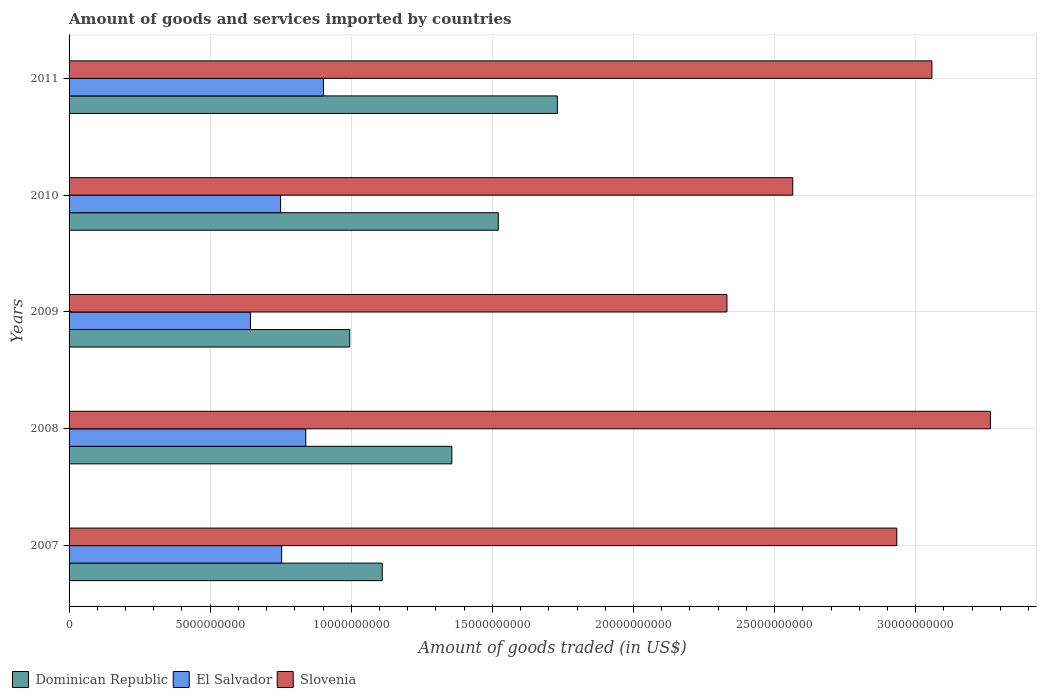Are the number of bars per tick equal to the number of legend labels?
Keep it short and to the point. Yes. What is the total amount of goods and services imported in Slovenia in 2010?
Your answer should be compact. 2.56e+1. Across all years, what is the maximum total amount of goods and services imported in Slovenia?
Ensure brevity in your answer.  3.26e+1. Across all years, what is the minimum total amount of goods and services imported in El Salvador?
Make the answer very short. 6.43e+09. In which year was the total amount of goods and services imported in Slovenia minimum?
Offer a terse response. 2009. What is the total total amount of goods and services imported in Dominican Republic in the graph?
Offer a terse response. 6.71e+1. What is the difference between the total amount of goods and services imported in Dominican Republic in 2010 and that in 2011?
Give a very brief answer. -2.09e+09. What is the difference between the total amount of goods and services imported in Dominican Republic in 2010 and the total amount of goods and services imported in El Salvador in 2008?
Provide a short and direct response. 6.82e+09. What is the average total amount of goods and services imported in Dominican Republic per year?
Your answer should be compact. 1.34e+1. In the year 2009, what is the difference between the total amount of goods and services imported in Dominican Republic and total amount of goods and services imported in El Salvador?
Your response must be concise. 3.52e+09. What is the ratio of the total amount of goods and services imported in El Salvador in 2008 to that in 2009?
Ensure brevity in your answer.  1.3. Is the difference between the total amount of goods and services imported in Dominican Republic in 2010 and 2011 greater than the difference between the total amount of goods and services imported in El Salvador in 2010 and 2011?
Your answer should be compact. No. What is the difference between the highest and the second highest total amount of goods and services imported in Dominican Republic?
Give a very brief answer. 2.09e+09. What is the difference between the highest and the lowest total amount of goods and services imported in Slovenia?
Ensure brevity in your answer.  9.34e+09. In how many years, is the total amount of goods and services imported in El Salvador greater than the average total amount of goods and services imported in El Salvador taken over all years?
Provide a succinct answer. 2. Is the sum of the total amount of goods and services imported in Dominican Republic in 2007 and 2011 greater than the maximum total amount of goods and services imported in El Salvador across all years?
Your answer should be very brief. Yes. What does the 3rd bar from the top in 2008 represents?
Make the answer very short. Dominican Republic. What does the 1st bar from the bottom in 2007 represents?
Offer a very short reply. Dominican Republic. How many bars are there?
Your answer should be very brief. 15. What is the difference between two consecutive major ticks on the X-axis?
Make the answer very short. 5.00e+09. Does the graph contain grids?
Your answer should be very brief. Yes. How many legend labels are there?
Your answer should be compact. 3. How are the legend labels stacked?
Your answer should be very brief. Horizontal. What is the title of the graph?
Provide a short and direct response. Amount of goods and services imported by countries. What is the label or title of the X-axis?
Make the answer very short. Amount of goods traded (in US$). What is the Amount of goods traded (in US$) in Dominican Republic in 2007?
Offer a terse response. 1.11e+1. What is the Amount of goods traded (in US$) of El Salvador in 2007?
Provide a succinct answer. 7.53e+09. What is the Amount of goods traded (in US$) in Slovenia in 2007?
Your response must be concise. 2.93e+1. What is the Amount of goods traded (in US$) of Dominican Republic in 2008?
Provide a short and direct response. 1.36e+1. What is the Amount of goods traded (in US$) in El Salvador in 2008?
Your response must be concise. 8.39e+09. What is the Amount of goods traded (in US$) in Slovenia in 2008?
Offer a terse response. 3.26e+1. What is the Amount of goods traded (in US$) in Dominican Republic in 2009?
Give a very brief answer. 9.95e+09. What is the Amount of goods traded (in US$) in El Salvador in 2009?
Give a very brief answer. 6.43e+09. What is the Amount of goods traded (in US$) in Slovenia in 2009?
Make the answer very short. 2.33e+1. What is the Amount of goods traded (in US$) of Dominican Republic in 2010?
Your answer should be compact. 1.52e+1. What is the Amount of goods traded (in US$) of El Salvador in 2010?
Offer a very short reply. 7.50e+09. What is the Amount of goods traded (in US$) of Slovenia in 2010?
Offer a very short reply. 2.56e+1. What is the Amount of goods traded (in US$) of Dominican Republic in 2011?
Offer a very short reply. 1.73e+1. What is the Amount of goods traded (in US$) of El Salvador in 2011?
Your answer should be compact. 9.01e+09. What is the Amount of goods traded (in US$) of Slovenia in 2011?
Provide a short and direct response. 3.06e+1. Across all years, what is the maximum Amount of goods traded (in US$) in Dominican Republic?
Offer a terse response. 1.73e+1. Across all years, what is the maximum Amount of goods traded (in US$) in El Salvador?
Make the answer very short. 9.01e+09. Across all years, what is the maximum Amount of goods traded (in US$) in Slovenia?
Your answer should be compact. 3.26e+1. Across all years, what is the minimum Amount of goods traded (in US$) of Dominican Republic?
Offer a terse response. 9.95e+09. Across all years, what is the minimum Amount of goods traded (in US$) in El Salvador?
Keep it short and to the point. 6.43e+09. Across all years, what is the minimum Amount of goods traded (in US$) of Slovenia?
Keep it short and to the point. 2.33e+1. What is the total Amount of goods traded (in US$) in Dominican Republic in the graph?
Your answer should be compact. 6.71e+1. What is the total Amount of goods traded (in US$) in El Salvador in the graph?
Keep it short and to the point. 3.89e+1. What is the total Amount of goods traded (in US$) in Slovenia in the graph?
Give a very brief answer. 1.42e+11. What is the difference between the Amount of goods traded (in US$) in Dominican Republic in 2007 and that in 2008?
Provide a succinct answer. -2.47e+09. What is the difference between the Amount of goods traded (in US$) in El Salvador in 2007 and that in 2008?
Give a very brief answer. -8.55e+08. What is the difference between the Amount of goods traded (in US$) in Slovenia in 2007 and that in 2008?
Provide a short and direct response. -3.32e+09. What is the difference between the Amount of goods traded (in US$) of Dominican Republic in 2007 and that in 2009?
Your answer should be compact. 1.15e+09. What is the difference between the Amount of goods traded (in US$) of El Salvador in 2007 and that in 2009?
Your answer should be compact. 1.10e+09. What is the difference between the Amount of goods traded (in US$) in Slovenia in 2007 and that in 2009?
Offer a terse response. 6.02e+09. What is the difference between the Amount of goods traded (in US$) of Dominican Republic in 2007 and that in 2010?
Your answer should be very brief. -4.11e+09. What is the difference between the Amount of goods traded (in US$) of El Salvador in 2007 and that in 2010?
Offer a terse response. 3.86e+07. What is the difference between the Amount of goods traded (in US$) of Slovenia in 2007 and that in 2010?
Give a very brief answer. 3.69e+09. What is the difference between the Amount of goods traded (in US$) of Dominican Republic in 2007 and that in 2011?
Provide a succinct answer. -6.20e+09. What is the difference between the Amount of goods traded (in US$) in El Salvador in 2007 and that in 2011?
Offer a terse response. -1.48e+09. What is the difference between the Amount of goods traded (in US$) in Slovenia in 2007 and that in 2011?
Your answer should be very brief. -1.24e+09. What is the difference between the Amount of goods traded (in US$) of Dominican Republic in 2008 and that in 2009?
Your answer should be compact. 3.62e+09. What is the difference between the Amount of goods traded (in US$) in El Salvador in 2008 and that in 2009?
Give a very brief answer. 1.96e+09. What is the difference between the Amount of goods traded (in US$) of Slovenia in 2008 and that in 2009?
Your answer should be very brief. 9.34e+09. What is the difference between the Amount of goods traded (in US$) of Dominican Republic in 2008 and that in 2010?
Ensure brevity in your answer.  -1.65e+09. What is the difference between the Amount of goods traded (in US$) in El Salvador in 2008 and that in 2010?
Offer a very short reply. 8.93e+08. What is the difference between the Amount of goods traded (in US$) of Slovenia in 2008 and that in 2010?
Offer a terse response. 7.00e+09. What is the difference between the Amount of goods traded (in US$) of Dominican Republic in 2008 and that in 2011?
Offer a terse response. -3.74e+09. What is the difference between the Amount of goods traded (in US$) of El Salvador in 2008 and that in 2011?
Keep it short and to the point. -6.26e+08. What is the difference between the Amount of goods traded (in US$) in Slovenia in 2008 and that in 2011?
Keep it short and to the point. 2.07e+09. What is the difference between the Amount of goods traded (in US$) of Dominican Republic in 2009 and that in 2010?
Offer a very short reply. -5.26e+09. What is the difference between the Amount of goods traded (in US$) of El Salvador in 2009 and that in 2010?
Provide a short and direct response. -1.07e+09. What is the difference between the Amount of goods traded (in US$) of Slovenia in 2009 and that in 2010?
Offer a terse response. -2.33e+09. What is the difference between the Amount of goods traded (in US$) in Dominican Republic in 2009 and that in 2011?
Your answer should be very brief. -7.36e+09. What is the difference between the Amount of goods traded (in US$) of El Salvador in 2009 and that in 2011?
Provide a succinct answer. -2.58e+09. What is the difference between the Amount of goods traded (in US$) in Slovenia in 2009 and that in 2011?
Keep it short and to the point. -7.26e+09. What is the difference between the Amount of goods traded (in US$) in Dominican Republic in 2010 and that in 2011?
Give a very brief answer. -2.09e+09. What is the difference between the Amount of goods traded (in US$) in El Salvador in 2010 and that in 2011?
Give a very brief answer. -1.52e+09. What is the difference between the Amount of goods traded (in US$) of Slovenia in 2010 and that in 2011?
Offer a terse response. -4.93e+09. What is the difference between the Amount of goods traded (in US$) in Dominican Republic in 2007 and the Amount of goods traded (in US$) in El Salvador in 2008?
Ensure brevity in your answer.  2.71e+09. What is the difference between the Amount of goods traded (in US$) of Dominican Republic in 2007 and the Amount of goods traded (in US$) of Slovenia in 2008?
Offer a very short reply. -2.16e+1. What is the difference between the Amount of goods traded (in US$) of El Salvador in 2007 and the Amount of goods traded (in US$) of Slovenia in 2008?
Ensure brevity in your answer.  -2.51e+1. What is the difference between the Amount of goods traded (in US$) in Dominican Republic in 2007 and the Amount of goods traded (in US$) in El Salvador in 2009?
Your answer should be compact. 4.67e+09. What is the difference between the Amount of goods traded (in US$) in Dominican Republic in 2007 and the Amount of goods traded (in US$) in Slovenia in 2009?
Keep it short and to the point. -1.22e+1. What is the difference between the Amount of goods traded (in US$) of El Salvador in 2007 and the Amount of goods traded (in US$) of Slovenia in 2009?
Provide a short and direct response. -1.58e+1. What is the difference between the Amount of goods traded (in US$) of Dominican Republic in 2007 and the Amount of goods traded (in US$) of El Salvador in 2010?
Provide a succinct answer. 3.60e+09. What is the difference between the Amount of goods traded (in US$) in Dominican Republic in 2007 and the Amount of goods traded (in US$) in Slovenia in 2010?
Your response must be concise. -1.45e+1. What is the difference between the Amount of goods traded (in US$) in El Salvador in 2007 and the Amount of goods traded (in US$) in Slovenia in 2010?
Your response must be concise. -1.81e+1. What is the difference between the Amount of goods traded (in US$) of Dominican Republic in 2007 and the Amount of goods traded (in US$) of El Salvador in 2011?
Give a very brief answer. 2.08e+09. What is the difference between the Amount of goods traded (in US$) in Dominican Republic in 2007 and the Amount of goods traded (in US$) in Slovenia in 2011?
Your answer should be compact. -1.95e+1. What is the difference between the Amount of goods traded (in US$) in El Salvador in 2007 and the Amount of goods traded (in US$) in Slovenia in 2011?
Offer a very short reply. -2.30e+1. What is the difference between the Amount of goods traded (in US$) of Dominican Republic in 2008 and the Amount of goods traded (in US$) of El Salvador in 2009?
Provide a succinct answer. 7.13e+09. What is the difference between the Amount of goods traded (in US$) in Dominican Republic in 2008 and the Amount of goods traded (in US$) in Slovenia in 2009?
Provide a short and direct response. -9.75e+09. What is the difference between the Amount of goods traded (in US$) of El Salvador in 2008 and the Amount of goods traded (in US$) of Slovenia in 2009?
Provide a succinct answer. -1.49e+1. What is the difference between the Amount of goods traded (in US$) in Dominican Republic in 2008 and the Amount of goods traded (in US$) in El Salvador in 2010?
Offer a very short reply. 6.07e+09. What is the difference between the Amount of goods traded (in US$) in Dominican Republic in 2008 and the Amount of goods traded (in US$) in Slovenia in 2010?
Keep it short and to the point. -1.21e+1. What is the difference between the Amount of goods traded (in US$) of El Salvador in 2008 and the Amount of goods traded (in US$) of Slovenia in 2010?
Your answer should be very brief. -1.73e+1. What is the difference between the Amount of goods traded (in US$) of Dominican Republic in 2008 and the Amount of goods traded (in US$) of El Salvador in 2011?
Provide a short and direct response. 4.55e+09. What is the difference between the Amount of goods traded (in US$) of Dominican Republic in 2008 and the Amount of goods traded (in US$) of Slovenia in 2011?
Provide a succinct answer. -1.70e+1. What is the difference between the Amount of goods traded (in US$) in El Salvador in 2008 and the Amount of goods traded (in US$) in Slovenia in 2011?
Make the answer very short. -2.22e+1. What is the difference between the Amount of goods traded (in US$) of Dominican Republic in 2009 and the Amount of goods traded (in US$) of El Salvador in 2010?
Your response must be concise. 2.45e+09. What is the difference between the Amount of goods traded (in US$) of Dominican Republic in 2009 and the Amount of goods traded (in US$) of Slovenia in 2010?
Offer a very short reply. -1.57e+1. What is the difference between the Amount of goods traded (in US$) of El Salvador in 2009 and the Amount of goods traded (in US$) of Slovenia in 2010?
Offer a terse response. -1.92e+1. What is the difference between the Amount of goods traded (in US$) of Dominican Republic in 2009 and the Amount of goods traded (in US$) of El Salvador in 2011?
Provide a succinct answer. 9.31e+08. What is the difference between the Amount of goods traded (in US$) of Dominican Republic in 2009 and the Amount of goods traded (in US$) of Slovenia in 2011?
Provide a short and direct response. -2.06e+1. What is the difference between the Amount of goods traded (in US$) of El Salvador in 2009 and the Amount of goods traded (in US$) of Slovenia in 2011?
Keep it short and to the point. -2.41e+1. What is the difference between the Amount of goods traded (in US$) of Dominican Republic in 2010 and the Amount of goods traded (in US$) of El Salvador in 2011?
Keep it short and to the point. 6.20e+09. What is the difference between the Amount of goods traded (in US$) in Dominican Republic in 2010 and the Amount of goods traded (in US$) in Slovenia in 2011?
Your response must be concise. -1.54e+1. What is the difference between the Amount of goods traded (in US$) in El Salvador in 2010 and the Amount of goods traded (in US$) in Slovenia in 2011?
Your answer should be compact. -2.31e+1. What is the average Amount of goods traded (in US$) of Dominican Republic per year?
Keep it short and to the point. 1.34e+1. What is the average Amount of goods traded (in US$) of El Salvador per year?
Your answer should be compact. 7.77e+09. What is the average Amount of goods traded (in US$) in Slovenia per year?
Make the answer very short. 2.83e+1. In the year 2007, what is the difference between the Amount of goods traded (in US$) in Dominican Republic and Amount of goods traded (in US$) in El Salvador?
Your answer should be very brief. 3.56e+09. In the year 2007, what is the difference between the Amount of goods traded (in US$) of Dominican Republic and Amount of goods traded (in US$) of Slovenia?
Keep it short and to the point. -1.82e+1. In the year 2007, what is the difference between the Amount of goods traded (in US$) in El Salvador and Amount of goods traded (in US$) in Slovenia?
Your response must be concise. -2.18e+1. In the year 2008, what is the difference between the Amount of goods traded (in US$) of Dominican Republic and Amount of goods traded (in US$) of El Salvador?
Provide a succinct answer. 5.18e+09. In the year 2008, what is the difference between the Amount of goods traded (in US$) of Dominican Republic and Amount of goods traded (in US$) of Slovenia?
Your response must be concise. -1.91e+1. In the year 2008, what is the difference between the Amount of goods traded (in US$) of El Salvador and Amount of goods traded (in US$) of Slovenia?
Offer a terse response. -2.43e+1. In the year 2009, what is the difference between the Amount of goods traded (in US$) of Dominican Republic and Amount of goods traded (in US$) of El Salvador?
Ensure brevity in your answer.  3.52e+09. In the year 2009, what is the difference between the Amount of goods traded (in US$) in Dominican Republic and Amount of goods traded (in US$) in Slovenia?
Offer a very short reply. -1.34e+1. In the year 2009, what is the difference between the Amount of goods traded (in US$) of El Salvador and Amount of goods traded (in US$) of Slovenia?
Your answer should be compact. -1.69e+1. In the year 2010, what is the difference between the Amount of goods traded (in US$) of Dominican Republic and Amount of goods traded (in US$) of El Salvador?
Your answer should be very brief. 7.71e+09. In the year 2010, what is the difference between the Amount of goods traded (in US$) of Dominican Republic and Amount of goods traded (in US$) of Slovenia?
Provide a succinct answer. -1.04e+1. In the year 2010, what is the difference between the Amount of goods traded (in US$) of El Salvador and Amount of goods traded (in US$) of Slovenia?
Your answer should be very brief. -1.81e+1. In the year 2011, what is the difference between the Amount of goods traded (in US$) of Dominican Republic and Amount of goods traded (in US$) of El Salvador?
Keep it short and to the point. 8.29e+09. In the year 2011, what is the difference between the Amount of goods traded (in US$) in Dominican Republic and Amount of goods traded (in US$) in Slovenia?
Your answer should be compact. -1.33e+1. In the year 2011, what is the difference between the Amount of goods traded (in US$) in El Salvador and Amount of goods traded (in US$) in Slovenia?
Your response must be concise. -2.16e+1. What is the ratio of the Amount of goods traded (in US$) of Dominican Republic in 2007 to that in 2008?
Make the answer very short. 0.82. What is the ratio of the Amount of goods traded (in US$) of El Salvador in 2007 to that in 2008?
Your answer should be compact. 0.9. What is the ratio of the Amount of goods traded (in US$) of Slovenia in 2007 to that in 2008?
Give a very brief answer. 0.9. What is the ratio of the Amount of goods traded (in US$) of Dominican Republic in 2007 to that in 2009?
Provide a short and direct response. 1.12. What is the ratio of the Amount of goods traded (in US$) of El Salvador in 2007 to that in 2009?
Keep it short and to the point. 1.17. What is the ratio of the Amount of goods traded (in US$) of Slovenia in 2007 to that in 2009?
Offer a terse response. 1.26. What is the ratio of the Amount of goods traded (in US$) of Dominican Republic in 2007 to that in 2010?
Give a very brief answer. 0.73. What is the ratio of the Amount of goods traded (in US$) of Slovenia in 2007 to that in 2010?
Make the answer very short. 1.14. What is the ratio of the Amount of goods traded (in US$) of Dominican Republic in 2007 to that in 2011?
Offer a very short reply. 0.64. What is the ratio of the Amount of goods traded (in US$) in El Salvador in 2007 to that in 2011?
Keep it short and to the point. 0.84. What is the ratio of the Amount of goods traded (in US$) in Slovenia in 2007 to that in 2011?
Offer a very short reply. 0.96. What is the ratio of the Amount of goods traded (in US$) in Dominican Republic in 2008 to that in 2009?
Provide a short and direct response. 1.36. What is the ratio of the Amount of goods traded (in US$) in El Salvador in 2008 to that in 2009?
Offer a terse response. 1.3. What is the ratio of the Amount of goods traded (in US$) in Slovenia in 2008 to that in 2009?
Provide a succinct answer. 1.4. What is the ratio of the Amount of goods traded (in US$) in Dominican Republic in 2008 to that in 2010?
Your response must be concise. 0.89. What is the ratio of the Amount of goods traded (in US$) of El Salvador in 2008 to that in 2010?
Offer a very short reply. 1.12. What is the ratio of the Amount of goods traded (in US$) of Slovenia in 2008 to that in 2010?
Offer a very short reply. 1.27. What is the ratio of the Amount of goods traded (in US$) in Dominican Republic in 2008 to that in 2011?
Offer a terse response. 0.78. What is the ratio of the Amount of goods traded (in US$) in El Salvador in 2008 to that in 2011?
Provide a short and direct response. 0.93. What is the ratio of the Amount of goods traded (in US$) in Slovenia in 2008 to that in 2011?
Your answer should be compact. 1.07. What is the ratio of the Amount of goods traded (in US$) of Dominican Republic in 2009 to that in 2010?
Your response must be concise. 0.65. What is the ratio of the Amount of goods traded (in US$) in El Salvador in 2009 to that in 2010?
Ensure brevity in your answer.  0.86. What is the ratio of the Amount of goods traded (in US$) in Slovenia in 2009 to that in 2010?
Offer a very short reply. 0.91. What is the ratio of the Amount of goods traded (in US$) of Dominican Republic in 2009 to that in 2011?
Provide a succinct answer. 0.57. What is the ratio of the Amount of goods traded (in US$) in El Salvador in 2009 to that in 2011?
Make the answer very short. 0.71. What is the ratio of the Amount of goods traded (in US$) in Slovenia in 2009 to that in 2011?
Ensure brevity in your answer.  0.76. What is the ratio of the Amount of goods traded (in US$) in Dominican Republic in 2010 to that in 2011?
Your answer should be compact. 0.88. What is the ratio of the Amount of goods traded (in US$) in El Salvador in 2010 to that in 2011?
Your response must be concise. 0.83. What is the ratio of the Amount of goods traded (in US$) of Slovenia in 2010 to that in 2011?
Your answer should be very brief. 0.84. What is the difference between the highest and the second highest Amount of goods traded (in US$) of Dominican Republic?
Keep it short and to the point. 2.09e+09. What is the difference between the highest and the second highest Amount of goods traded (in US$) in El Salvador?
Your response must be concise. 6.26e+08. What is the difference between the highest and the second highest Amount of goods traded (in US$) of Slovenia?
Your response must be concise. 2.07e+09. What is the difference between the highest and the lowest Amount of goods traded (in US$) in Dominican Republic?
Ensure brevity in your answer.  7.36e+09. What is the difference between the highest and the lowest Amount of goods traded (in US$) in El Salvador?
Your answer should be very brief. 2.58e+09. What is the difference between the highest and the lowest Amount of goods traded (in US$) of Slovenia?
Your response must be concise. 9.34e+09. 